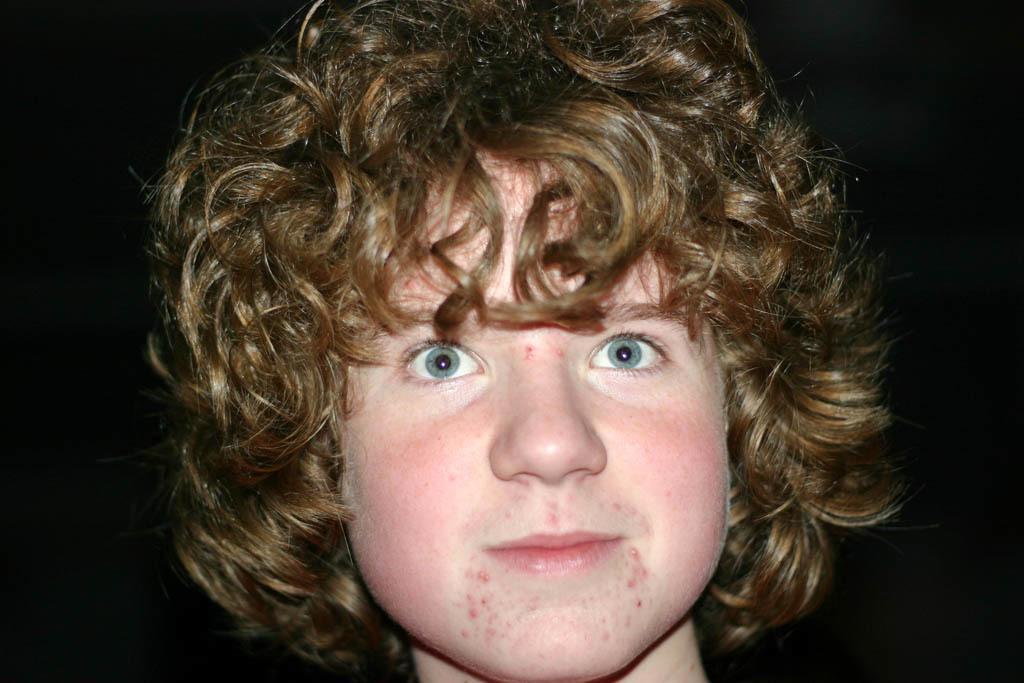Please provide a concise description of this image. In this picture there is a person with blue eyes and gold hair and with pink cheeks. 